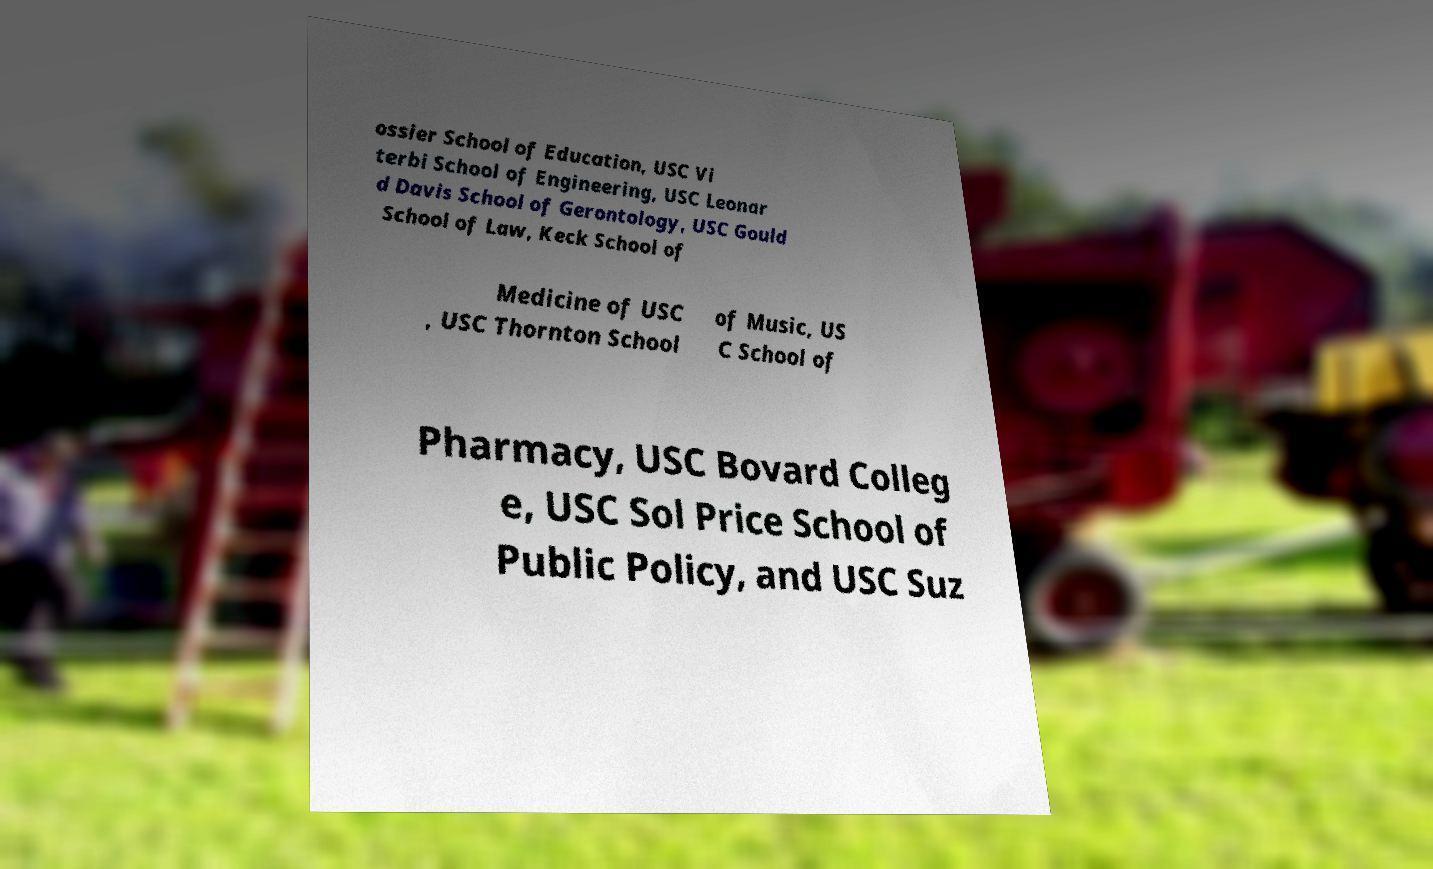Can you read and provide the text displayed in the image?This photo seems to have some interesting text. Can you extract and type it out for me? ossier School of Education, USC Vi terbi School of Engineering, USC Leonar d Davis School of Gerontology, USC Gould School of Law, Keck School of Medicine of USC , USC Thornton School of Music, US C School of Pharmacy, USC Bovard Colleg e, USC Sol Price School of Public Policy, and USC Suz 